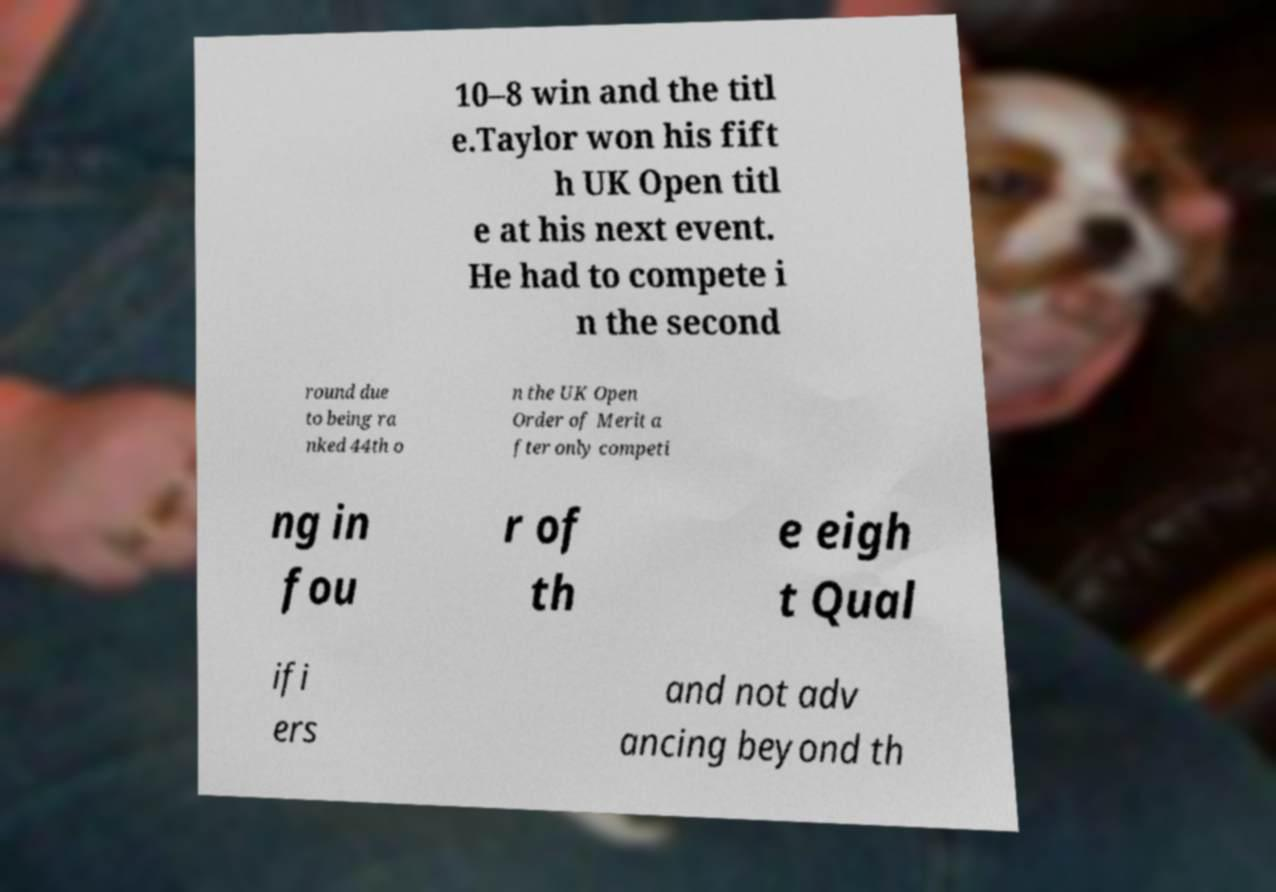Can you read and provide the text displayed in the image?This photo seems to have some interesting text. Can you extract and type it out for me? 10–8 win and the titl e.Taylor won his fift h UK Open titl e at his next event. He had to compete i n the second round due to being ra nked 44th o n the UK Open Order of Merit a fter only competi ng in fou r of th e eigh t Qual ifi ers and not adv ancing beyond th 